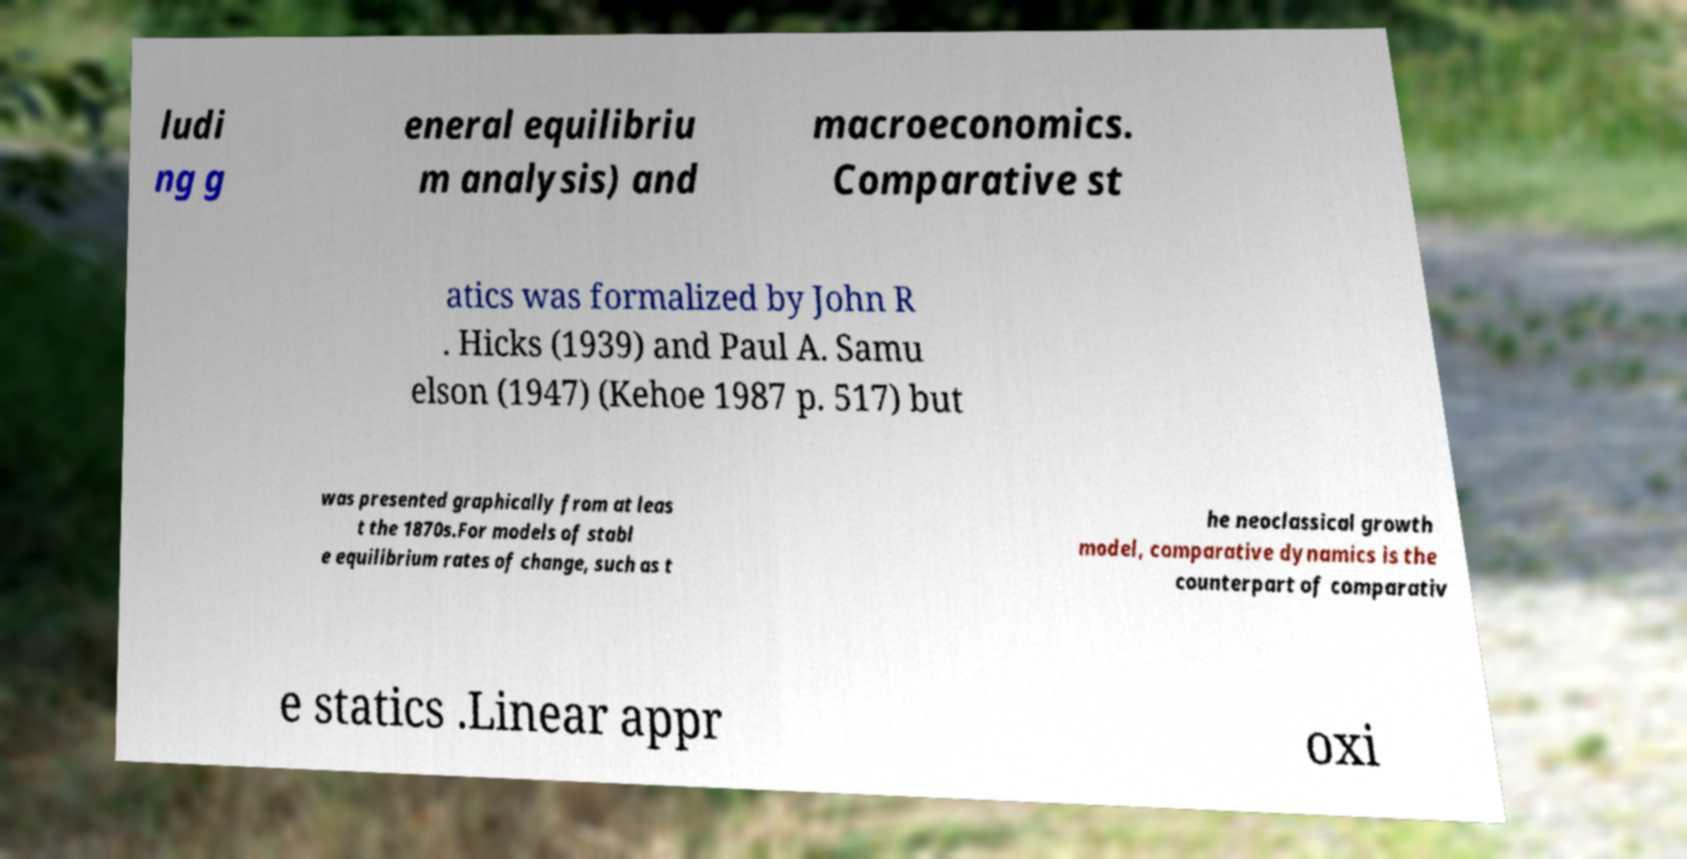Please read and relay the text visible in this image. What does it say? ludi ng g eneral equilibriu m analysis) and macroeconomics. Comparative st atics was formalized by John R . Hicks (1939) and Paul A. Samu elson (1947) (Kehoe 1987 p. 517) but was presented graphically from at leas t the 1870s.For models of stabl e equilibrium rates of change, such as t he neoclassical growth model, comparative dynamics is the counterpart of comparativ e statics .Linear appr oxi 